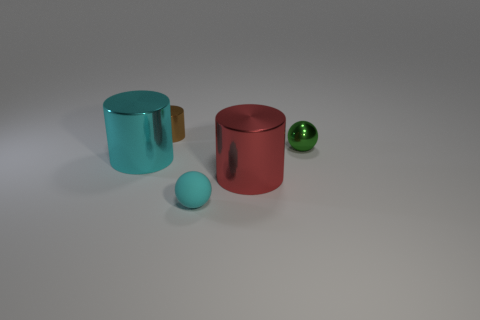Subtract all cyan metal cylinders. How many cylinders are left? 2 Subtract 1 cylinders. How many cylinders are left? 2 Add 1 cyan matte objects. How many objects exist? 6 Subtract all cylinders. How many objects are left? 2 Subtract 0 gray balls. How many objects are left? 5 Subtract all metallic cylinders. Subtract all large green shiny cylinders. How many objects are left? 2 Add 5 tiny shiny balls. How many tiny shiny balls are left? 6 Add 3 large gray cylinders. How many large gray cylinders exist? 3 